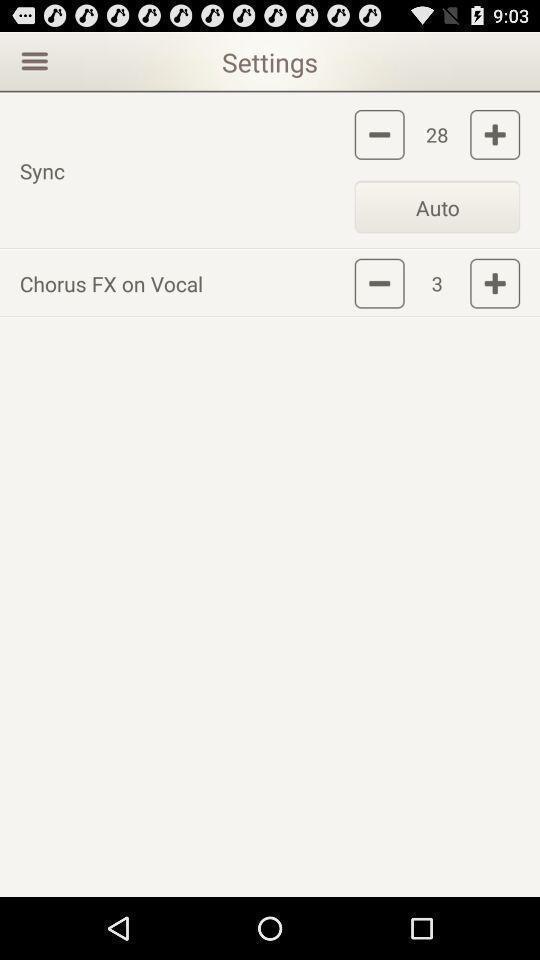Tell me what you see in this picture. Settings menu for music editing app. 